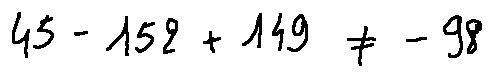Convert formula to latex. <formula><loc_0><loc_0><loc_500><loc_500>4 5 - 1 5 2 + 1 4 9 \neq - 9 8</formula> 